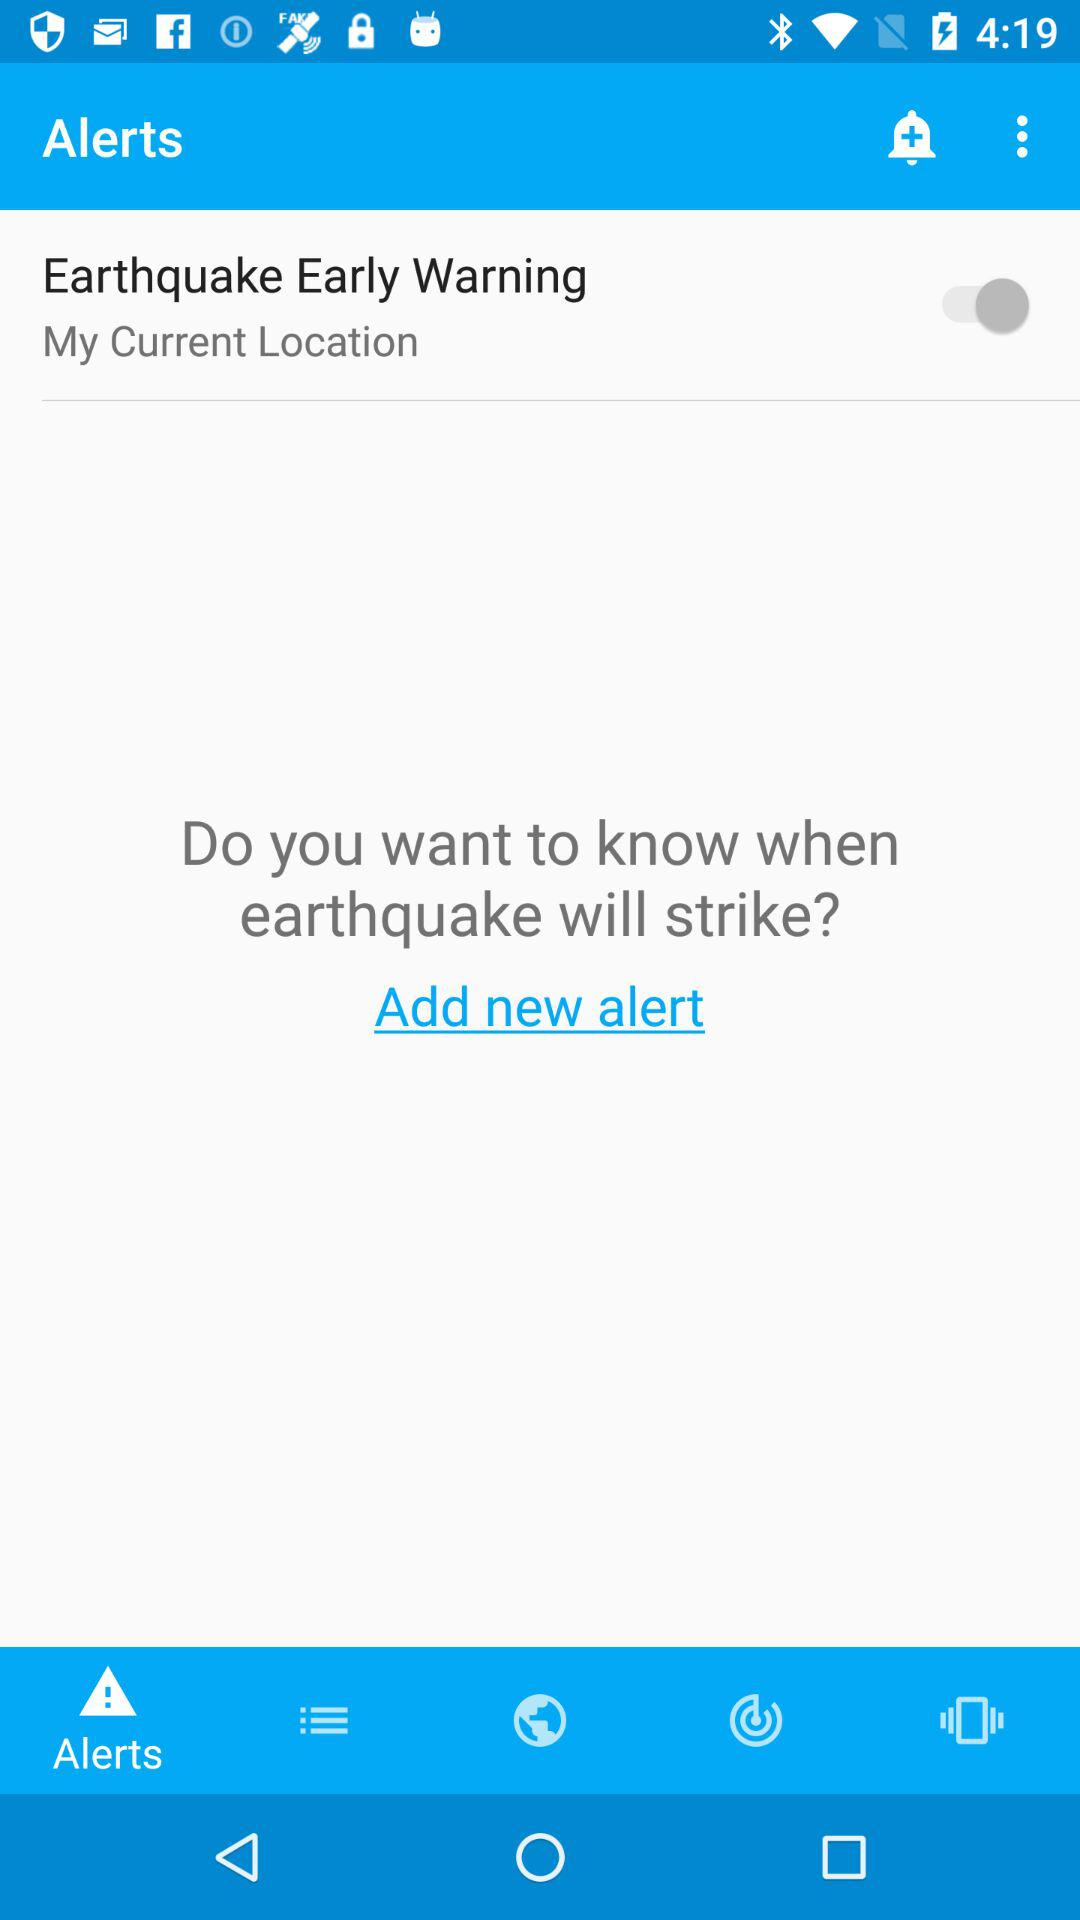What is the status of "Earthquake Early Warning"? The status is "off". 